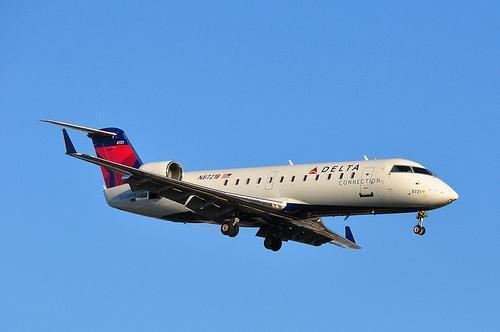How many clouds are in the sky?
Give a very brief answer. 0. How many dinosaurs are in the picture?
Give a very brief answer. 0. 